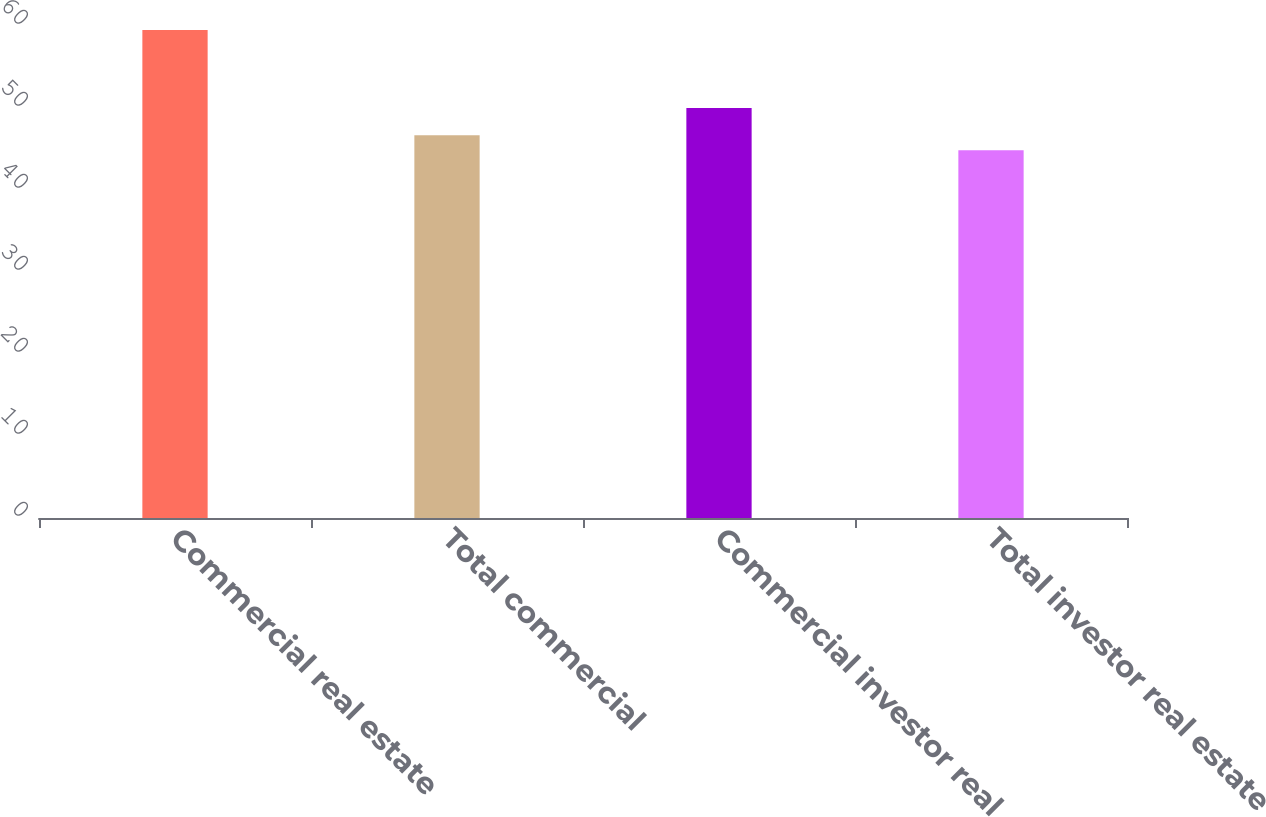<chart> <loc_0><loc_0><loc_500><loc_500><bar_chart><fcel>Commercial real estate<fcel>Total commercial<fcel>Commercial investor real<fcel>Total investor real estate<nl><fcel>59.5<fcel>46.69<fcel>50<fcel>44.86<nl></chart> 